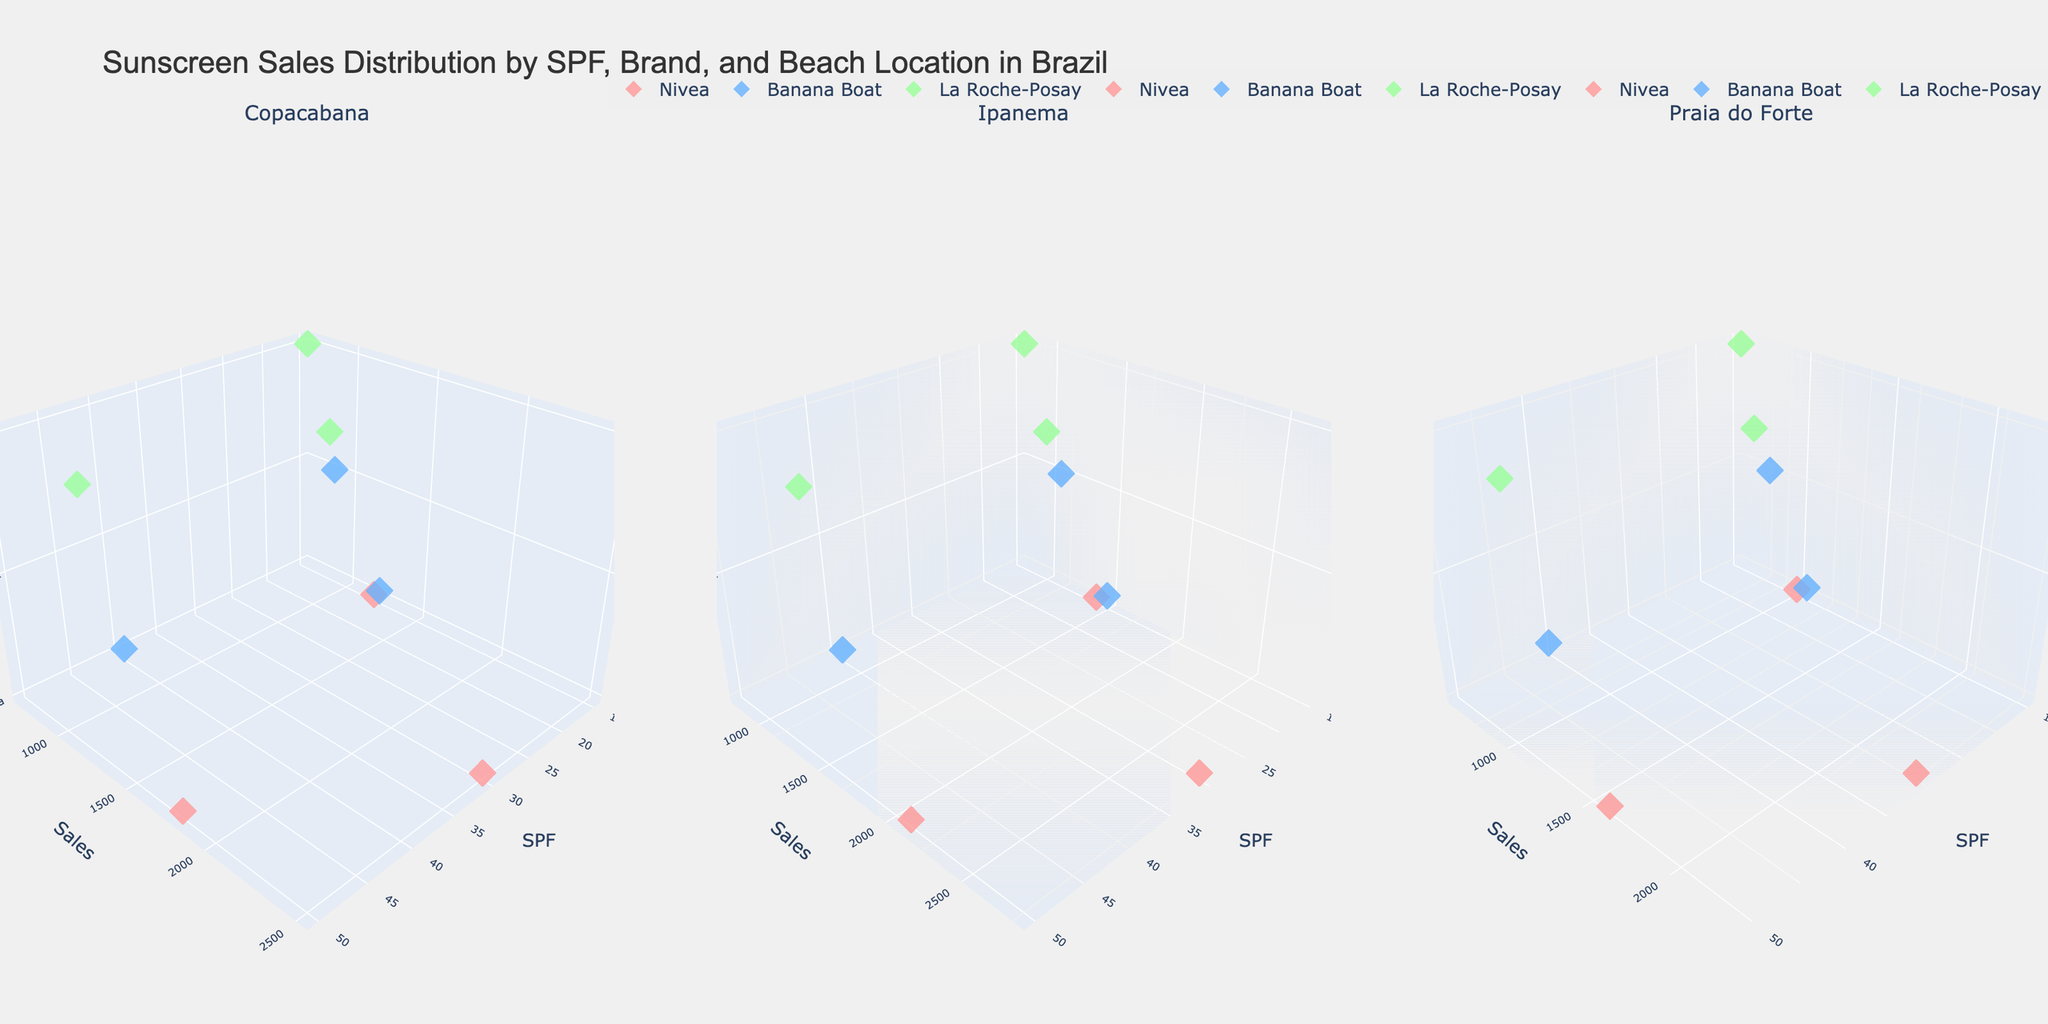Which beach has the highest sales for SPF 30 sunscreen? To determine this, note the highest point along the Sales axis for SPF 30 among the subplots. Ipanema has the highest sales for SPF 30.
Answer: Ipanema How do the sales for La Roche-Posay at Copacabana compare to those at Ipanema for SPF 50? Compare the height of the markers representing La Roche-Posay at both Copacabana and Ipanema for SPF 50. Copacabana is at a lower value compared to Ipanema.
Answer: Ipanema has higher sales What is the average sales for Nivea's sunscreens at Praia do Forte? Average sales can be calculated by summing the sales values for Nivea at Praia do Forte across all SPF levels and then dividing by the number of SPF levels. Sum (1000 + 2300 + 1600) = 4900, and 4900 / 3 ≈ 1633.
Answer: 1633 Which brand shows the most consistent sales across different SPF levels at Ipanema? Consistency in sales can be seen from a small variation between the markers' heights for different SPF levels. Nivea shows the most consistent sales across SPF 15, 30, and 50.
Answer: Nivea At which location do Banana Boat's products have the lowest sales for SPF 15? Examine the lowest sales value for Banana Boat's SPF 15 across all subplots. Praia do Forte has the lowest sales for Banana Boat SPF 15.
Answer: Praia do Forte Are the sales of La Roche-Posay higher for SPF 30 or SPF 50 at Copacabana? Compare the heights of the sales markers for SPF 30 and SPF 50 for La Roche-Posay at Copacabana. The marker for SPF 30 is higher than that for SPF 50.
Answer: SPF 30 What is the total sales of all brands for SPF 50 at Ipanema? Sum the sales values for all brands for SPF 50 at Ipanema. Total: 2100 (Nivea) + 1700 (Banana Boat) + 1500 (La Roche-Posay) = 5300.
Answer: 5300 Which SPF level of Nivea has the lowest sales at Copacabana? Identify the lowest point along the Sales axis for Nivea at Copacabana. SPF 15 has the lowest sales for Nivea at Copacabana.
Answer: SPF 15 